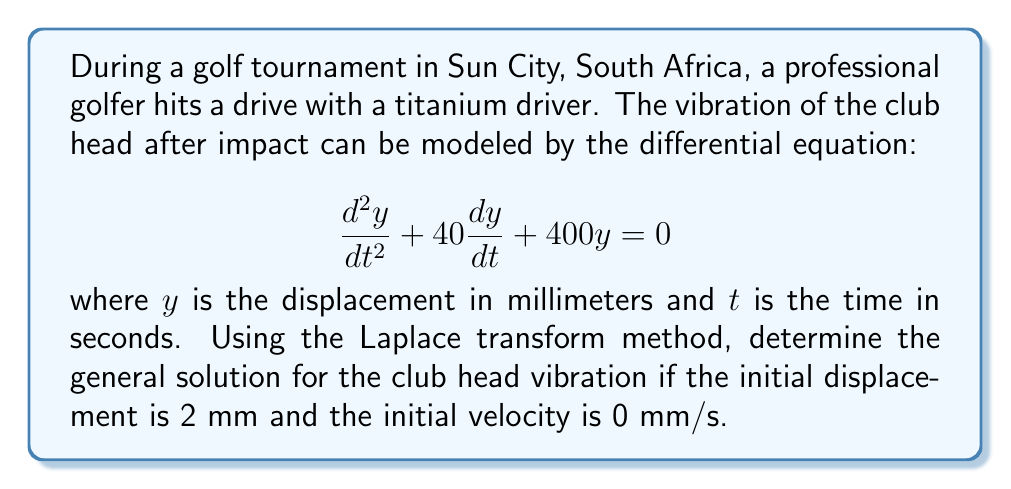Could you help me with this problem? Let's solve this step-by-step using the Laplace transform method:

1) First, we take the Laplace transform of both sides of the differential equation:

   $$\mathcal{L}\{y''\} + 40\mathcal{L}\{y'\} + 400\mathcal{L}\{y\} = 0$$

2) Using the Laplace transform properties:

   $$s^2Y(s) - sy(0) - y'(0) + 40[sY(s) - y(0)] + 400Y(s) = 0$$

3) Substitute the initial conditions: $y(0) = 2$ and $y'(0) = 0$

   $$s^2Y(s) - 2s + 40sY(s) - 80 + 400Y(s) = 0$$

4) Collect terms with $Y(s)$:

   $$(s^2 + 40s + 400)Y(s) = 2s + 80$$

5) Solve for $Y(s)$:

   $$Y(s) = \frac{2s + 80}{s^2 + 40s + 400} = \frac{2(s + 40)}{(s + 20)^2 + 300}$$

6) This is in the form of the Laplace transform of a damped cosine function. The inverse Laplace transform is:

   $$y(t) = 2e^{-20t}(\cos(\sqrt{300}t) + \frac{20}{\sqrt{300}}\sin(\sqrt{300}t))$$

7) Simplify $\sqrt{300} = 10\sqrt{3}$:

   $$y(t) = 2e^{-20t}(\cos(10\sqrt{3}t) + \frac{2}{\sqrt{3}}\sin(10\sqrt{3}t))$$

This is the general solution for the club head vibration.
Answer: $$y(t) = 2e^{-20t}(\cos(10\sqrt{3}t) + \frac{2}{\sqrt{3}}\sin(10\sqrt{3}t))$$ 